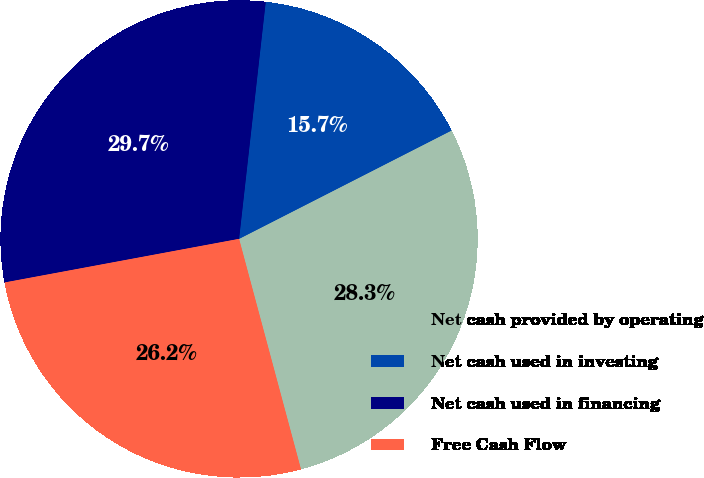Convert chart. <chart><loc_0><loc_0><loc_500><loc_500><pie_chart><fcel>Net cash provided by operating<fcel>Net cash used in investing<fcel>Net cash used in financing<fcel>Free Cash Flow<nl><fcel>28.33%<fcel>15.71%<fcel>29.71%<fcel>26.25%<nl></chart> 